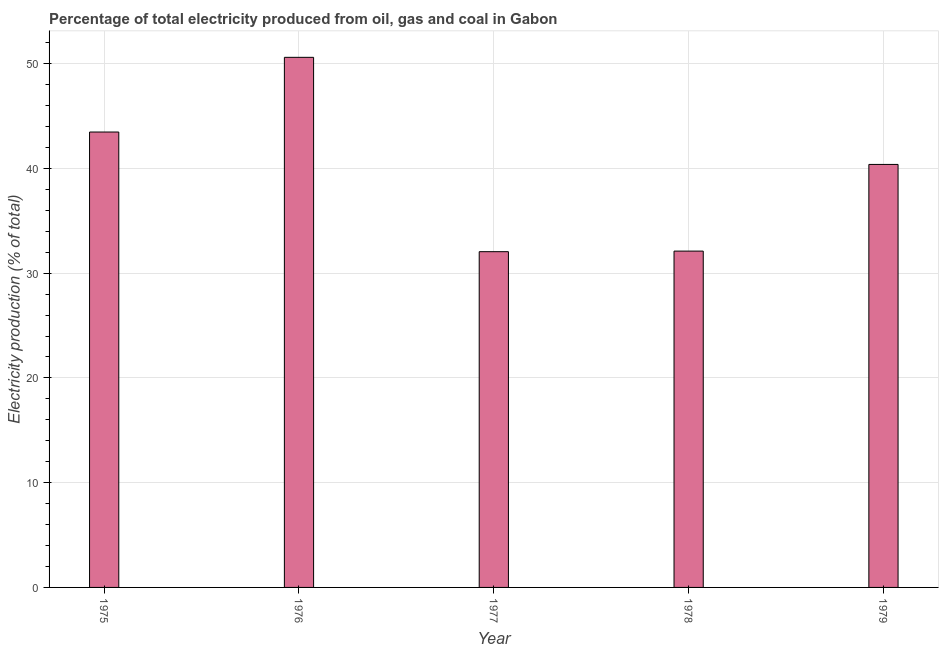Does the graph contain any zero values?
Your response must be concise. No. Does the graph contain grids?
Your answer should be very brief. Yes. What is the title of the graph?
Provide a short and direct response. Percentage of total electricity produced from oil, gas and coal in Gabon. What is the label or title of the X-axis?
Provide a short and direct response. Year. What is the label or title of the Y-axis?
Your answer should be compact. Electricity production (% of total). What is the electricity production in 1979?
Provide a succinct answer. 40.38. Across all years, what is the maximum electricity production?
Provide a succinct answer. 50.61. Across all years, what is the minimum electricity production?
Keep it short and to the point. 32.05. In which year was the electricity production maximum?
Make the answer very short. 1976. What is the sum of the electricity production?
Provide a short and direct response. 198.64. What is the difference between the electricity production in 1977 and 1979?
Provide a short and direct response. -8.33. What is the average electricity production per year?
Provide a short and direct response. 39.73. What is the median electricity production?
Make the answer very short. 40.38. Is the electricity production in 1977 less than that in 1979?
Make the answer very short. Yes. Is the difference between the electricity production in 1977 and 1978 greater than the difference between any two years?
Provide a succinct answer. No. What is the difference between the highest and the second highest electricity production?
Your answer should be very brief. 7.13. Is the sum of the electricity production in 1975 and 1979 greater than the maximum electricity production across all years?
Keep it short and to the point. Yes. What is the difference between the highest and the lowest electricity production?
Provide a succinct answer. 18.56. Are the values on the major ticks of Y-axis written in scientific E-notation?
Provide a short and direct response. No. What is the Electricity production (% of total) in 1975?
Give a very brief answer. 43.48. What is the Electricity production (% of total) in 1976?
Keep it short and to the point. 50.61. What is the Electricity production (% of total) of 1977?
Make the answer very short. 32.05. What is the Electricity production (% of total) in 1978?
Offer a very short reply. 32.11. What is the Electricity production (% of total) of 1979?
Provide a short and direct response. 40.38. What is the difference between the Electricity production (% of total) in 1975 and 1976?
Provide a succinct answer. -7.13. What is the difference between the Electricity production (% of total) in 1975 and 1977?
Offer a terse response. 11.42. What is the difference between the Electricity production (% of total) in 1975 and 1978?
Keep it short and to the point. 11.37. What is the difference between the Electricity production (% of total) in 1975 and 1979?
Keep it short and to the point. 3.09. What is the difference between the Electricity production (% of total) in 1976 and 1977?
Keep it short and to the point. 18.56. What is the difference between the Electricity production (% of total) in 1976 and 1978?
Your response must be concise. 18.5. What is the difference between the Electricity production (% of total) in 1976 and 1979?
Make the answer very short. 10.23. What is the difference between the Electricity production (% of total) in 1977 and 1978?
Give a very brief answer. -0.06. What is the difference between the Electricity production (% of total) in 1977 and 1979?
Ensure brevity in your answer.  -8.33. What is the difference between the Electricity production (% of total) in 1978 and 1979?
Offer a very short reply. -8.27. What is the ratio of the Electricity production (% of total) in 1975 to that in 1976?
Make the answer very short. 0.86. What is the ratio of the Electricity production (% of total) in 1975 to that in 1977?
Keep it short and to the point. 1.36. What is the ratio of the Electricity production (% of total) in 1975 to that in 1978?
Keep it short and to the point. 1.35. What is the ratio of the Electricity production (% of total) in 1975 to that in 1979?
Give a very brief answer. 1.08. What is the ratio of the Electricity production (% of total) in 1976 to that in 1977?
Provide a succinct answer. 1.58. What is the ratio of the Electricity production (% of total) in 1976 to that in 1978?
Keep it short and to the point. 1.58. What is the ratio of the Electricity production (% of total) in 1976 to that in 1979?
Give a very brief answer. 1.25. What is the ratio of the Electricity production (% of total) in 1977 to that in 1978?
Keep it short and to the point. 1. What is the ratio of the Electricity production (% of total) in 1977 to that in 1979?
Keep it short and to the point. 0.79. What is the ratio of the Electricity production (% of total) in 1978 to that in 1979?
Keep it short and to the point. 0.8. 